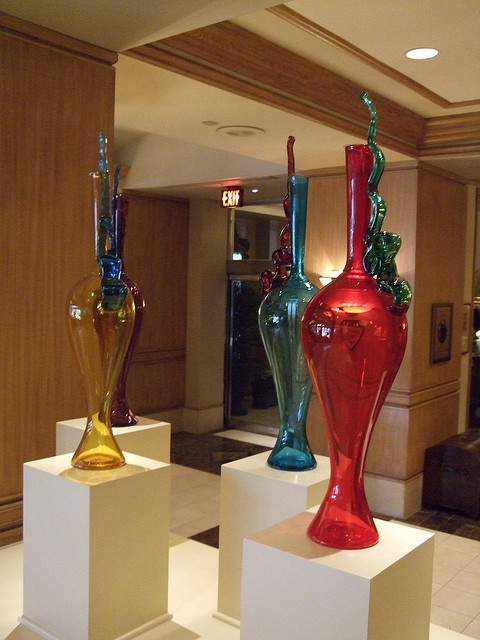Describe the objects in this image and their specific colors. I can see vase in olive, brown, and maroon tones, vase in olive, black, teal, gray, and maroon tones, vase in olive, maroon, and black tones, and vase in olive, black, maroon, and brown tones in this image. 